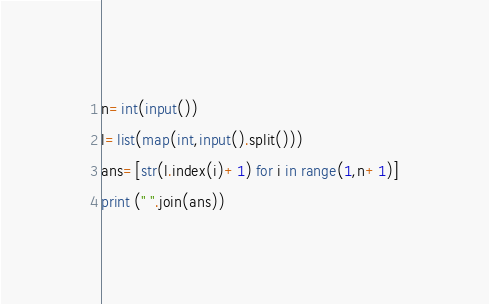Convert code to text. <code><loc_0><loc_0><loc_500><loc_500><_Python_>n=int(input())
l=list(map(int,input().split()))
ans=[str(l.index(i)+1) for i in range(1,n+1)]
print (" ".join(ans))</code> 